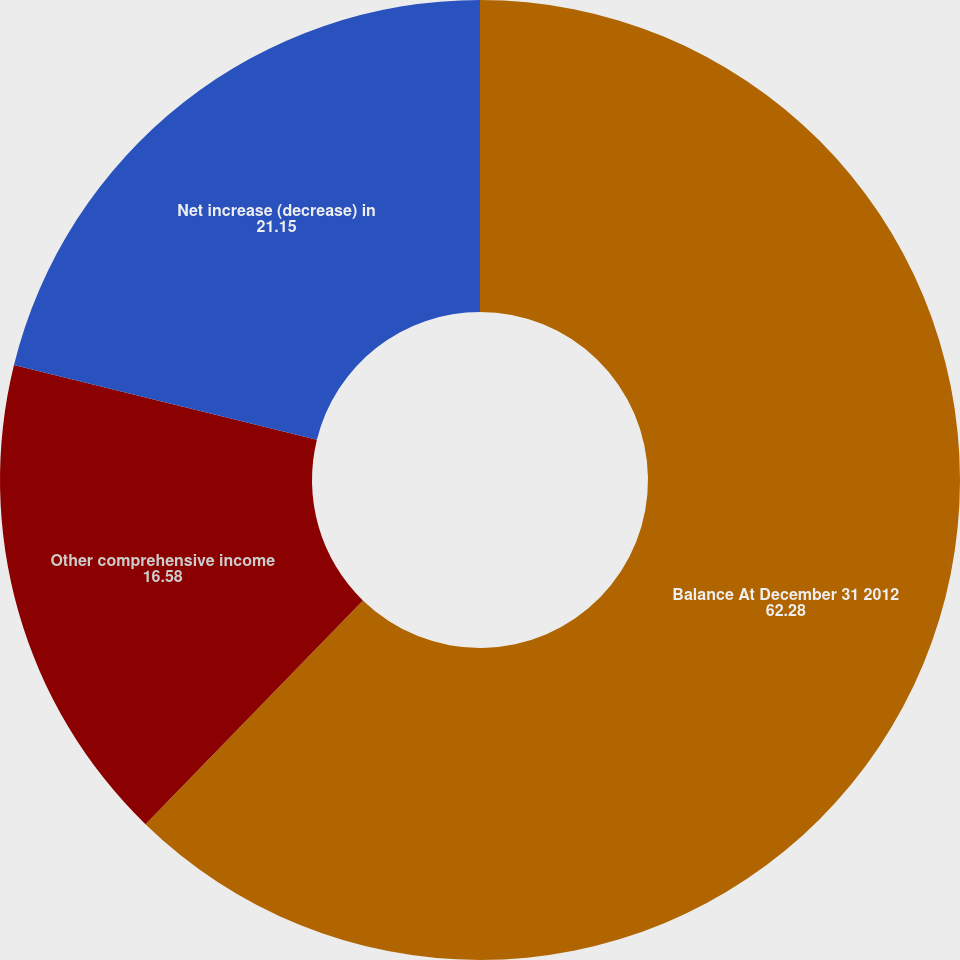Convert chart to OTSL. <chart><loc_0><loc_0><loc_500><loc_500><pie_chart><fcel>Balance At December 31 2012<fcel>Other comprehensive income<fcel>Net increase (decrease) in<nl><fcel>62.28%<fcel>16.58%<fcel>21.15%<nl></chart> 